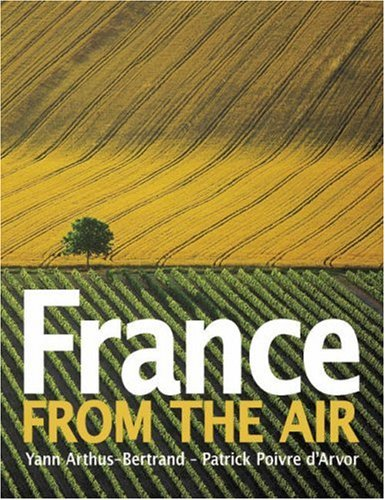Is this an art related book? Yes, it is an art-related book, beautifully integrating photography and artistic perspectives to showcase the beauty of France from above. 